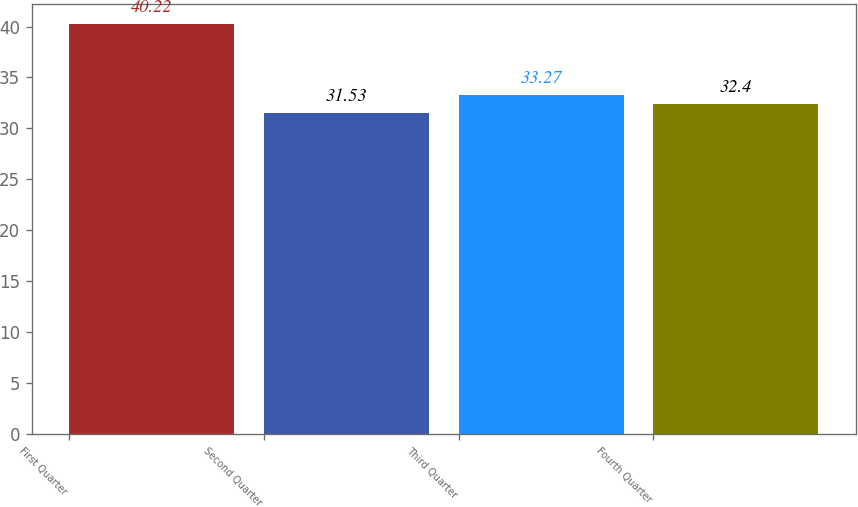<chart> <loc_0><loc_0><loc_500><loc_500><bar_chart><fcel>First Quarter<fcel>Second Quarter<fcel>Third Quarter<fcel>Fourth Quarter<nl><fcel>40.22<fcel>31.53<fcel>33.27<fcel>32.4<nl></chart> 